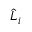Convert formula to latex. <formula><loc_0><loc_0><loc_500><loc_500>\widehat { L } _ { i }</formula> 